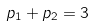<formula> <loc_0><loc_0><loc_500><loc_500>p _ { 1 } + p _ { 2 } = 3</formula> 